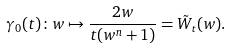Convert formula to latex. <formula><loc_0><loc_0><loc_500><loc_500>\gamma _ { 0 } ( t ) \colon w \mapsto \frac { 2 w } { t ( w ^ { n } + 1 ) } = \tilde { W } _ { t } ( w ) .</formula> 